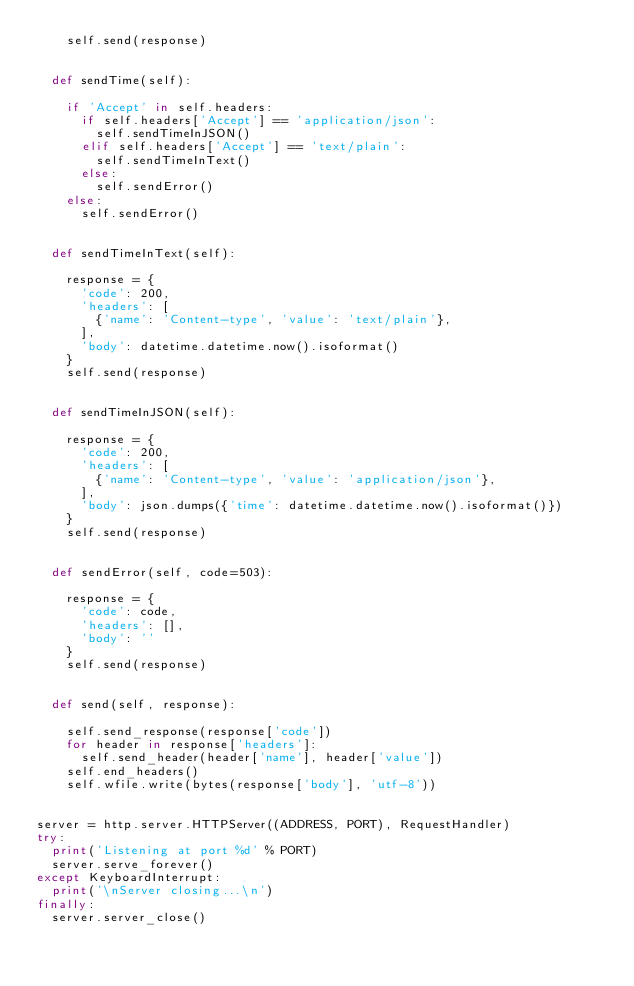<code> <loc_0><loc_0><loc_500><loc_500><_Python_>    self.send(response)


  def sendTime(self):

    if 'Accept' in self.headers:
      if self.headers['Accept'] == 'application/json':
        self.sendTimeInJSON()
      elif self.headers['Accept'] == 'text/plain':
        self.sendTimeInText()
      else:
        self.sendError() 
    else:
      self.sendError() 


  def sendTimeInText(self):

    response = {
      'code': 200,
      'headers': [
        {'name': 'Content-type', 'value': 'text/plain'},
      ],
      'body': datetime.datetime.now().isoformat()
    }
    self.send(response)


  def sendTimeInJSON(self):

    response = {
      'code': 200,
      'headers': [
        {'name': 'Content-type', 'value': 'application/json'},
      ],
      'body': json.dumps({'time': datetime.datetime.now().isoformat()})
    }
    self.send(response)


  def sendError(self, code=503):
    
    response = {
      'code': code, 
      'headers': [], 
      'body': ''
    }
    self.send(response)


  def send(self, response):

    self.send_response(response['code'])
    for header in response['headers']:
      self.send_header(header['name'], header['value'])
    self.end_headers()
    self.wfile.write(bytes(response['body'], 'utf-8'))


server = http.server.HTTPServer((ADDRESS, PORT), RequestHandler)
try:
  print('Listening at port %d' % PORT)
  server.serve_forever()
except KeyboardInterrupt:
  print('\nServer closing...\n')
finally:
  server.server_close()</code> 